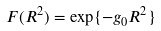<formula> <loc_0><loc_0><loc_500><loc_500>F ( R ^ { 2 } ) = \exp \{ - g _ { 0 } R ^ { 2 } \}</formula> 